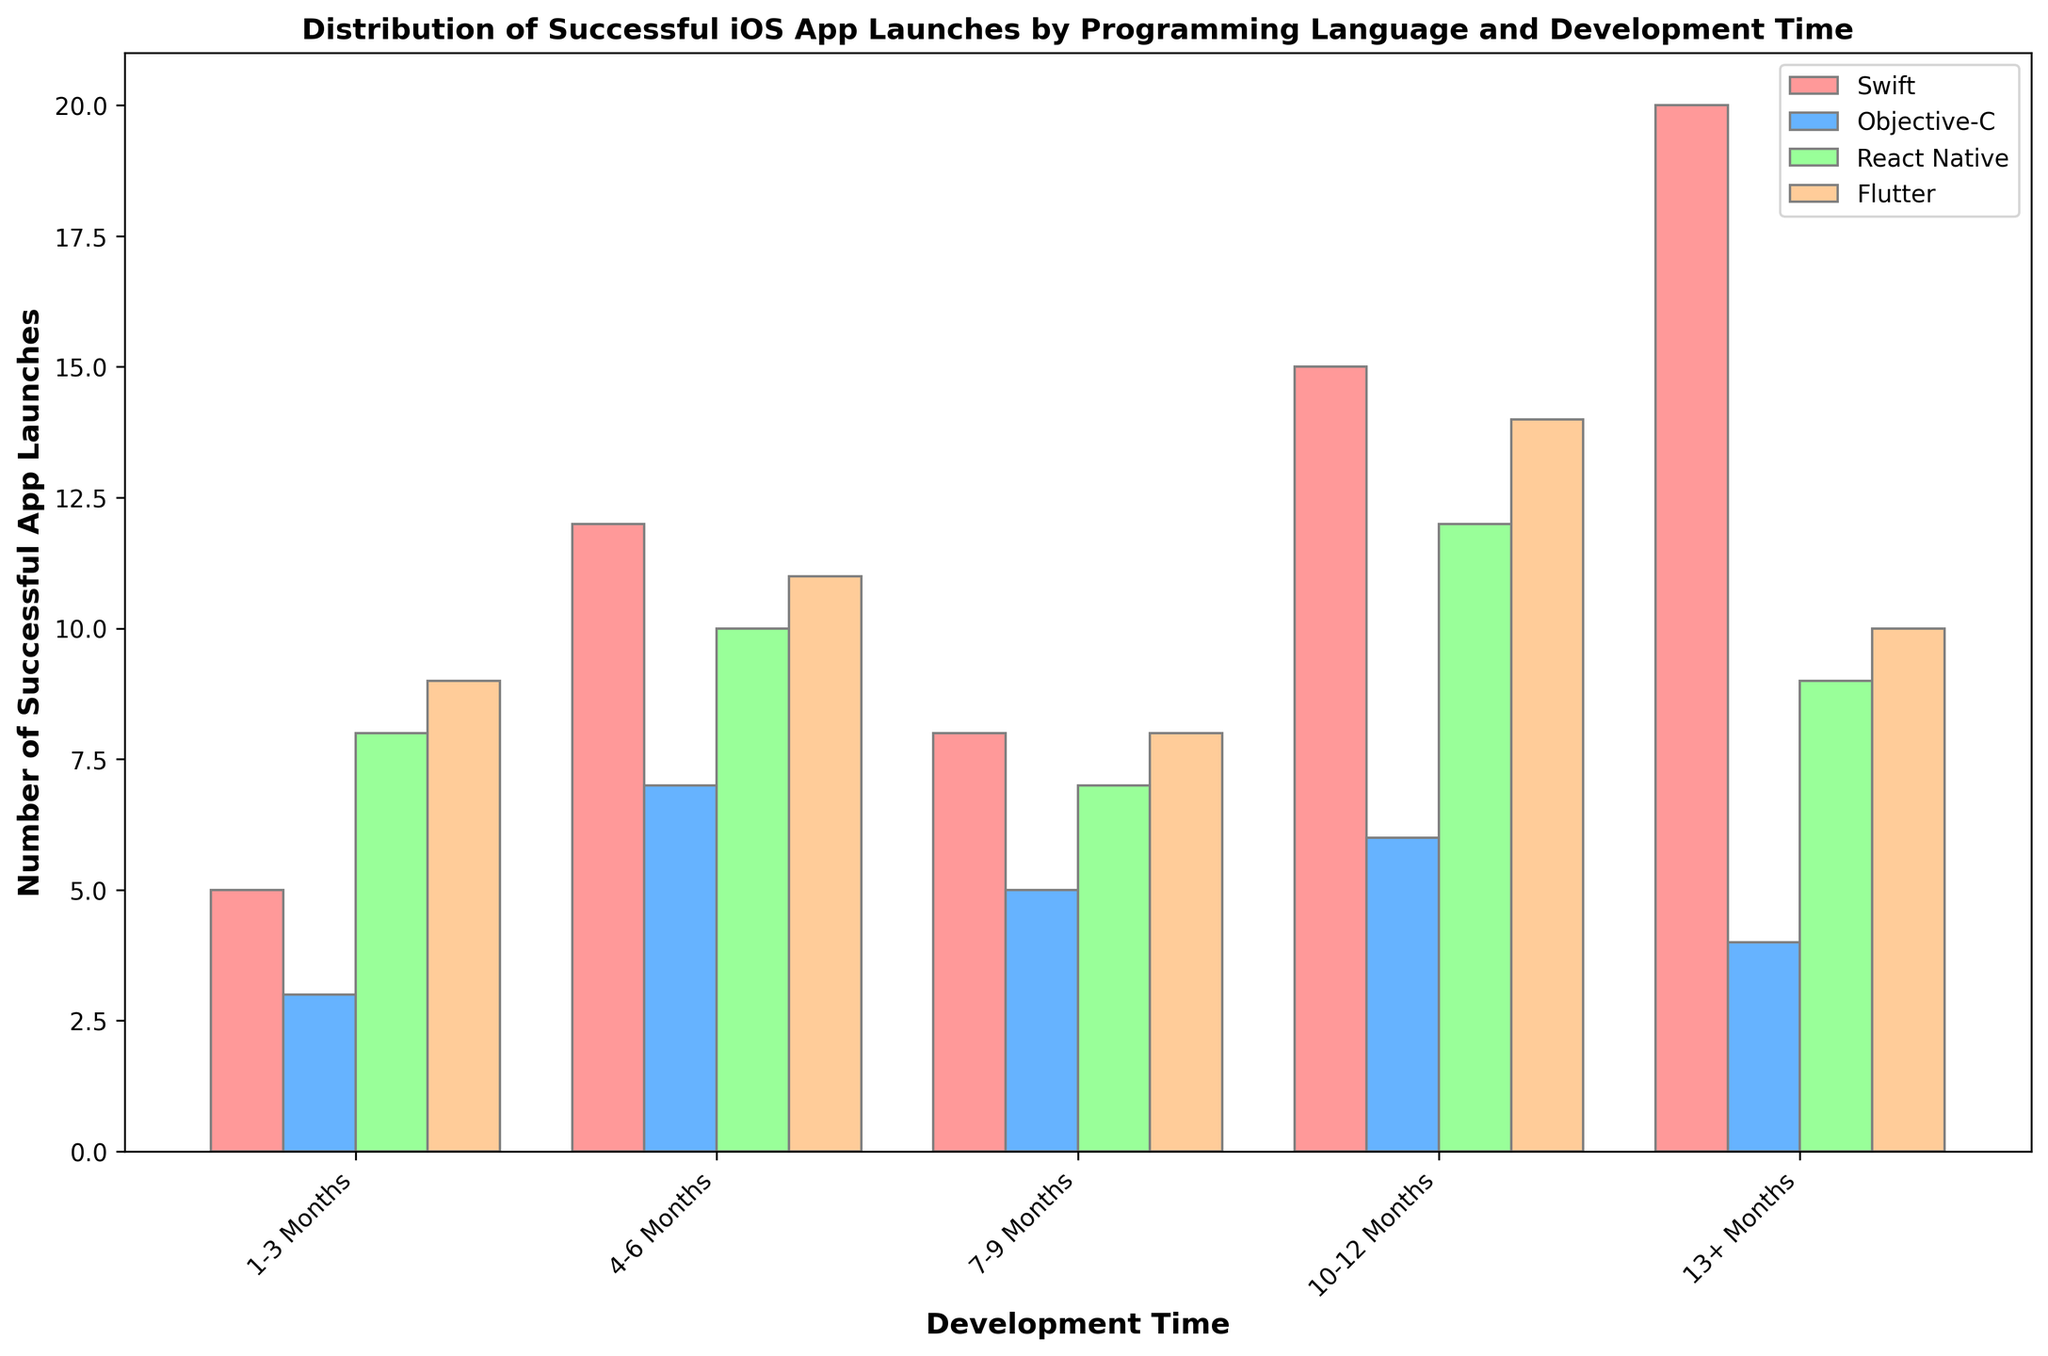What's the most common development time range for successful Swift app launches? The tallest bar representing Swift in the grouped bar plot indicates the most common development time range. For Swift, the 13+ Months range has the tallest bar.
Answer: 13+ Months Which programming language has the least successful launches in the 1-3 months development time range? Comparing the heights of the bars for all languages in the 1-3 Months range, Objective-C has the shortest bar, indicating the least number of successful launches.
Answer: Objective-C Among all the languages, which one has the highest number of successful launches in the 10-12 months range? The tallest bar in the 10-12 months range across all languages identifies the highest number of successful launches. Flutter has the tallest bar in this range.
Answer: Flutter How many more successful app launches does React Native have compared to Objective-C for development times beyond 13 months? For development times of 13+ months, React Native has 9 successful launches and Objective-C has 4. The difference is 9 - 4.
Answer: 5 What's the combined total of successful app launches for Swift and Flutter within the 7-9 months development time range? Adding up the counts for Swift and Flutter in the 7-9 months range, Swift has 8 and Flutter has 8. The total is 8 + 8.
Answer: 16 Which programming language shows a consistent increase in successful app launches as the development time increases, until the 10-12 months range? By inspecting the trend for each language across the development time ranges, Swift shows a consistent increase until 10-12 months, where it peaks before decreasing.
Answer: Swift For development times of 4-6 months, is the number of successful Flutter app launches greater than, less than, or equal to that of React Native? The heights of the bars for Flutter and React Native within the 4-6 months range show that Flutter has 11 successful launches, while React Native has 10.
Answer: Greater than How does the number of successful launches for Objective-C in the 4-6 months range compare to the number for React Native in the same range? The bar heights indicate that Objective-C has 7 successful launches in the 4-6 months range, while React Native has 10. Objective-C has fewer successful launches compared to React Native.
Answer: Fewer Across all languages, which development time range appears to have the most variable success rates? Observing the variation in bar heights across different development time ranges, the 1-3 months range shows a wide variability with bars of significantly different heights.
Answer: 1-3 Months What can you infer about the trend in successful app launches for Objective-C over increasing development times? Observing the bars for Objective-C over all development times, a slight rise is seen up to 10-12 months, followed by a drop at 13+ months, showing a peak at 10-12 months.
Answer: Peaks at 10-12 months 